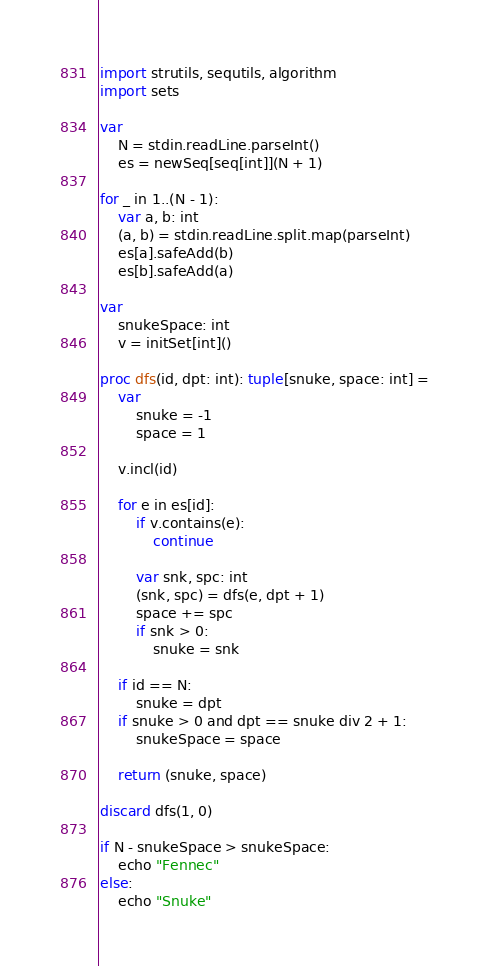Convert code to text. <code><loc_0><loc_0><loc_500><loc_500><_Nim_>import strutils, sequtils, algorithm
import sets

var
    N = stdin.readLine.parseInt()
    es = newSeq[seq[int]](N + 1)

for _ in 1..(N - 1):
    var a, b: int
    (a, b) = stdin.readLine.split.map(parseInt)
    es[a].safeAdd(b)
    es[b].safeAdd(a)

var
    snukeSpace: int
    v = initSet[int]()

proc dfs(id, dpt: int): tuple[snuke, space: int] =
    var
        snuke = -1
        space = 1
    
    v.incl(id)

    for e in es[id]:
        if v.contains(e):
            continue

        var snk, spc: int
        (snk, spc) = dfs(e, dpt + 1)
        space += spc
        if snk > 0:
            snuke = snk

    if id == N:
        snuke = dpt
    if snuke > 0 and dpt == snuke div 2 + 1:
        snukeSpace = space

    return (snuke, space)

discard dfs(1, 0)

if N - snukeSpace > snukeSpace:
    echo "Fennec"
else:
    echo "Snuke"</code> 